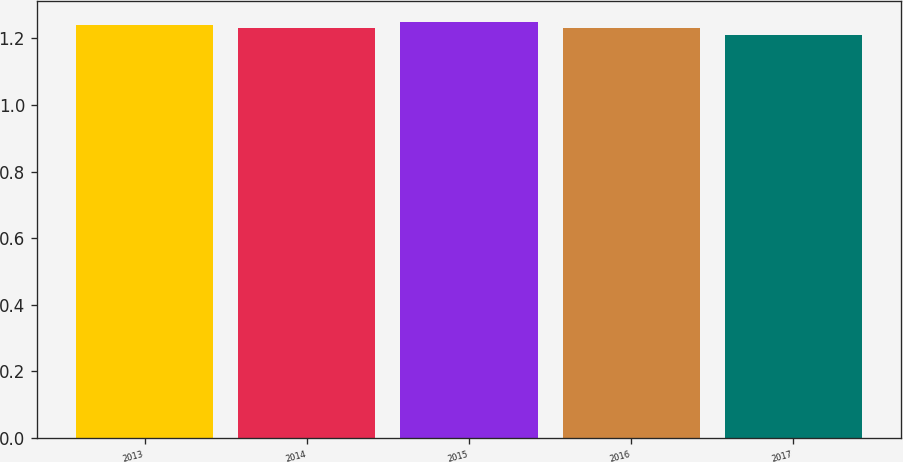Convert chart to OTSL. <chart><loc_0><loc_0><loc_500><loc_500><bar_chart><fcel>2013<fcel>2014<fcel>2015<fcel>2016<fcel>2017<nl><fcel>1.24<fcel>1.23<fcel>1.25<fcel>1.23<fcel>1.21<nl></chart> 